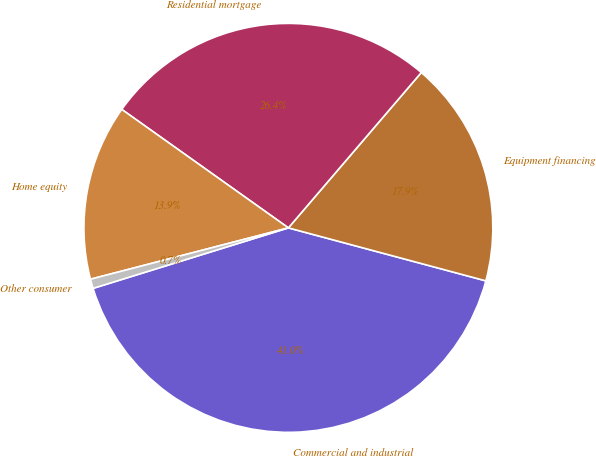Convert chart to OTSL. <chart><loc_0><loc_0><loc_500><loc_500><pie_chart><fcel>Commercial and industrial<fcel>Equipment financing<fcel>Residential mortgage<fcel>Home equity<fcel>Other consumer<nl><fcel>41.05%<fcel>17.91%<fcel>26.43%<fcel>13.88%<fcel>0.74%<nl></chart> 